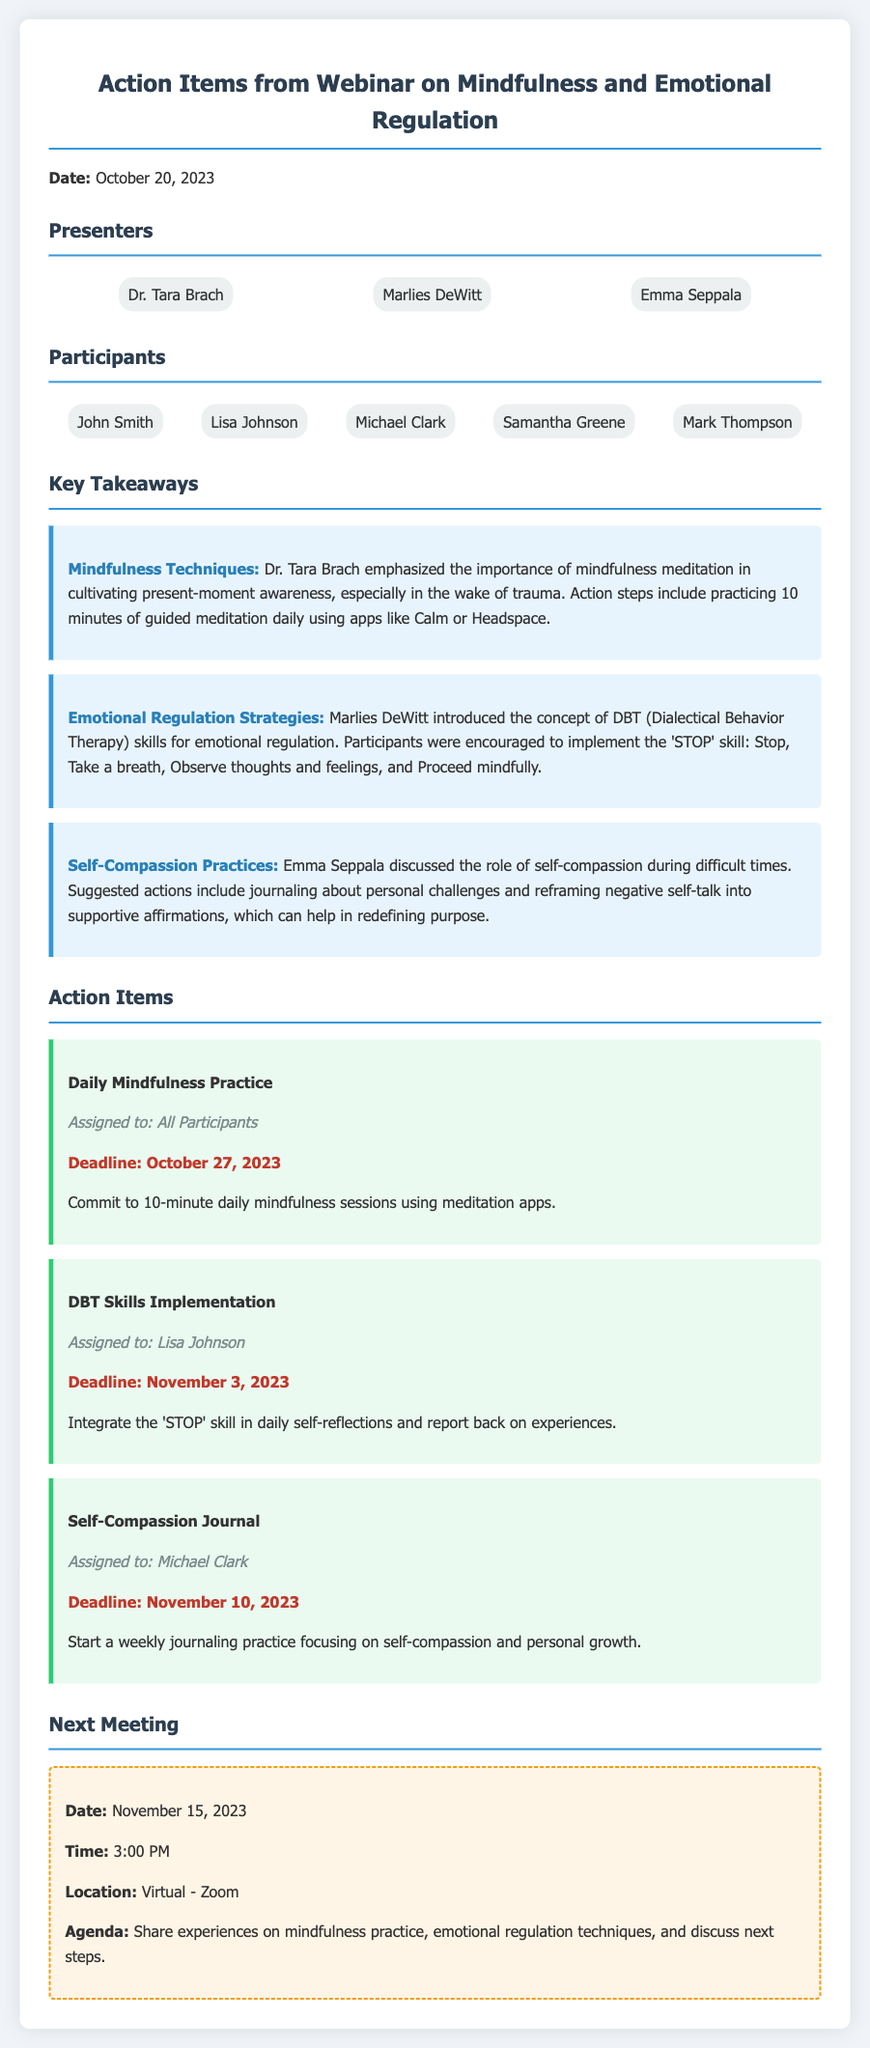What is the date of the webinar? The date mentioned in the document for the webinar is October 20, 2023.
Answer: October 20, 2023 Who is assigned to the self-compassion journal action item? The document states that Michael Clark is assigned to the self-compassion journal action item.
Answer: Michael Clark What is the deadline for the DBT skills implementation action item? The document specifies that the deadline for the DBT skills implementation is November 3, 2023.
Answer: November 3, 2023 What technique is emphasized by Dr. Tara Brach? The document indicates that Dr. Tara Brach emphasized mindfulness meditation as an important technique.
Answer: Mindfulness meditation How many presenters are listed in the document? The document lists three presenters, which are Dr. Tara Brach, Marlies DeWitt, and Emma Seppala.
Answer: Three What will be discussed in the next meeting? According to the document, the agenda for the next meeting includes sharing experiences on mindfulness practice and emotional regulation techniques.
Answer: Share experiences on mindfulness practice and emotional regulation techniques What is the assigned action item for all participants? The document specifies that all participants are to commit to 10-minute daily mindfulness sessions.
Answer: Daily Mindfulness Practice When is the next meeting scheduled? The document mentions that the next meeting is scheduled for November 15, 2023.
Answer: November 15, 2023 